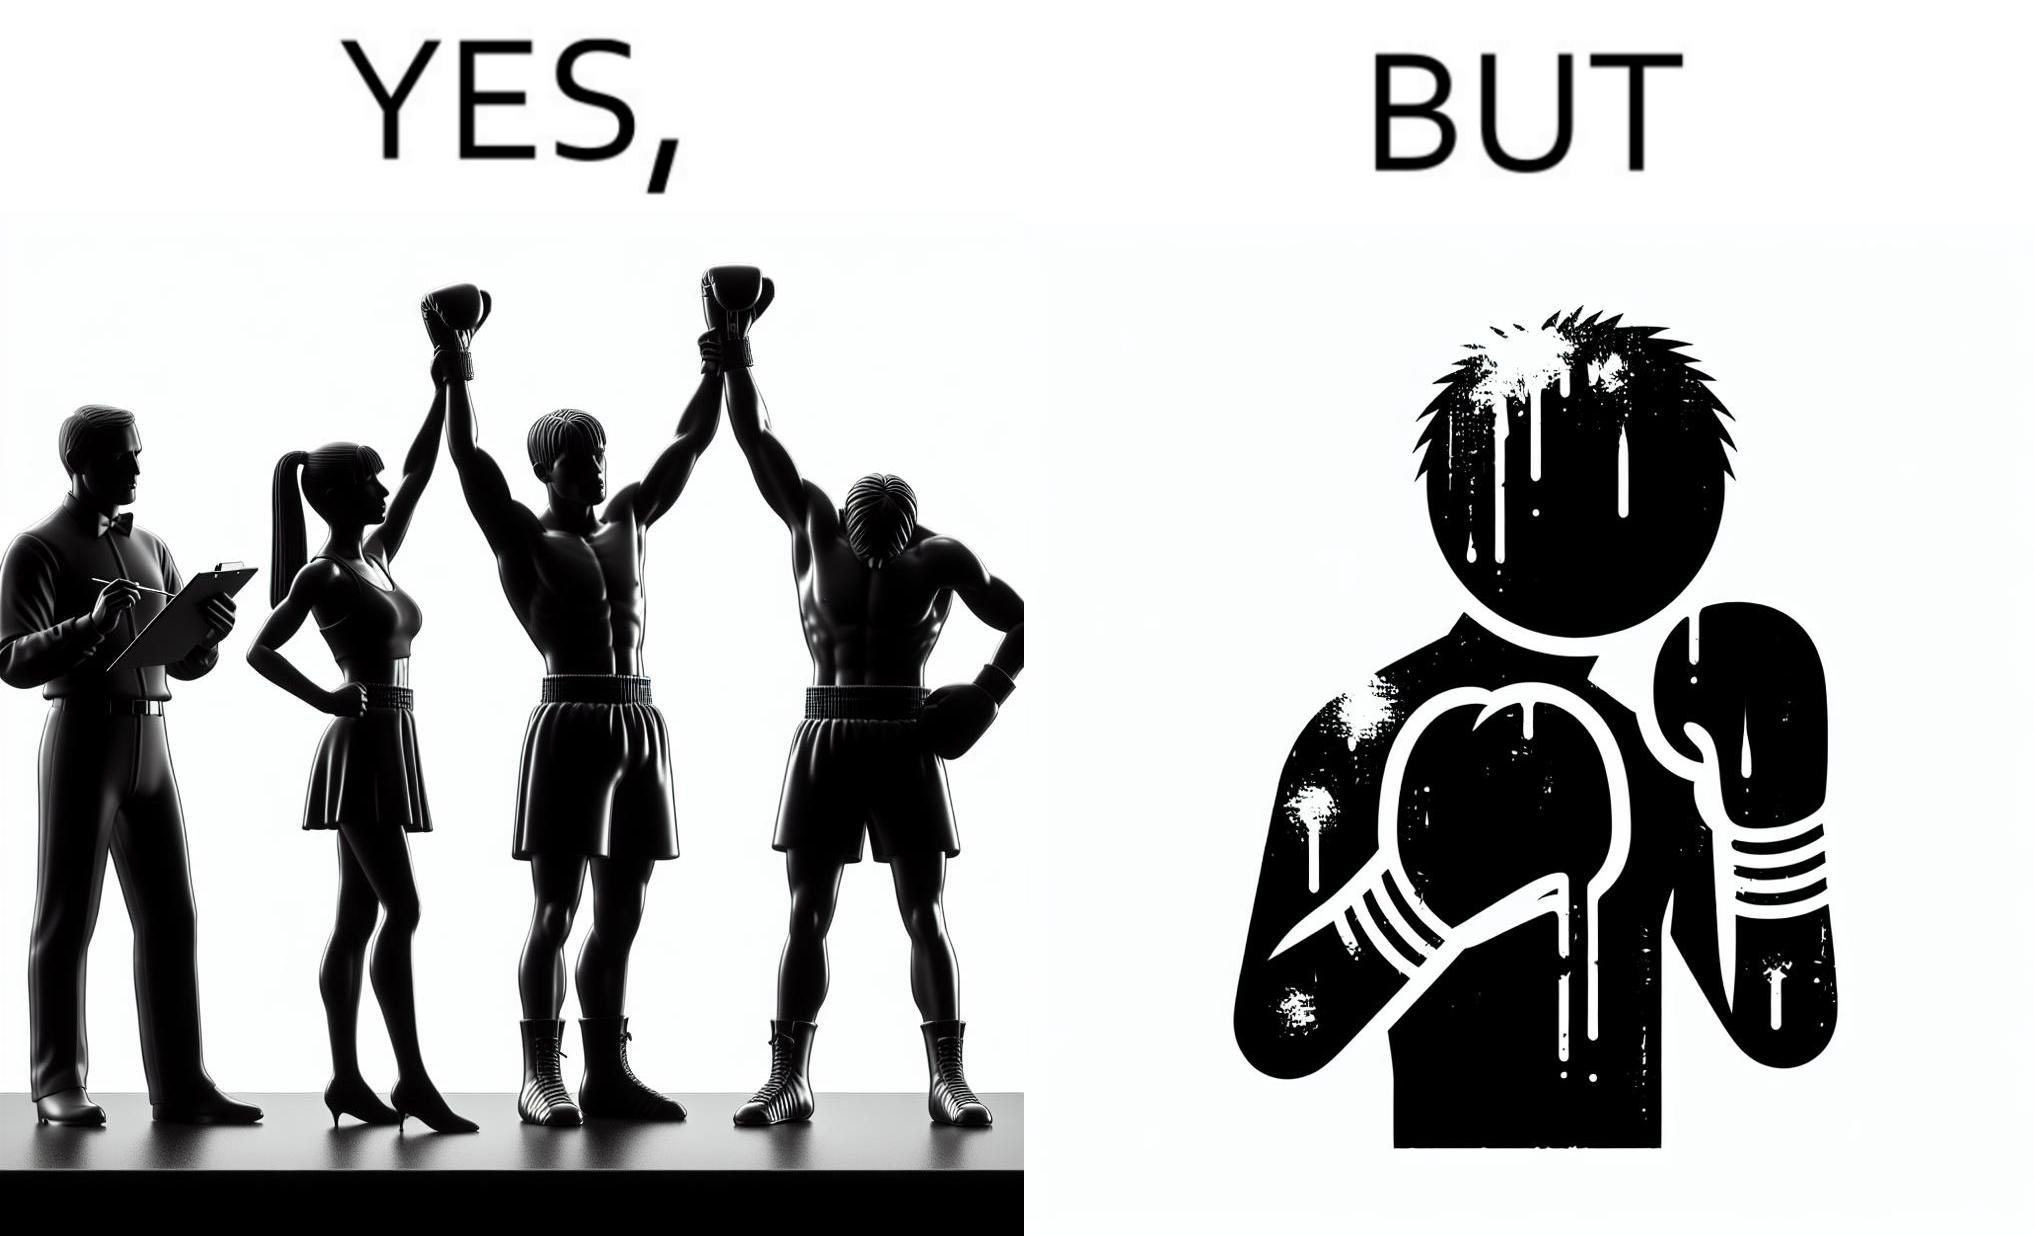What is shown in this image? The image is ironic because even though a boxer has won the match and it is supposed to be a moment of celebration, the boxer got bruised in several places during the match. This is an illustration of what hurdles a person has to go through in order to succeed. 